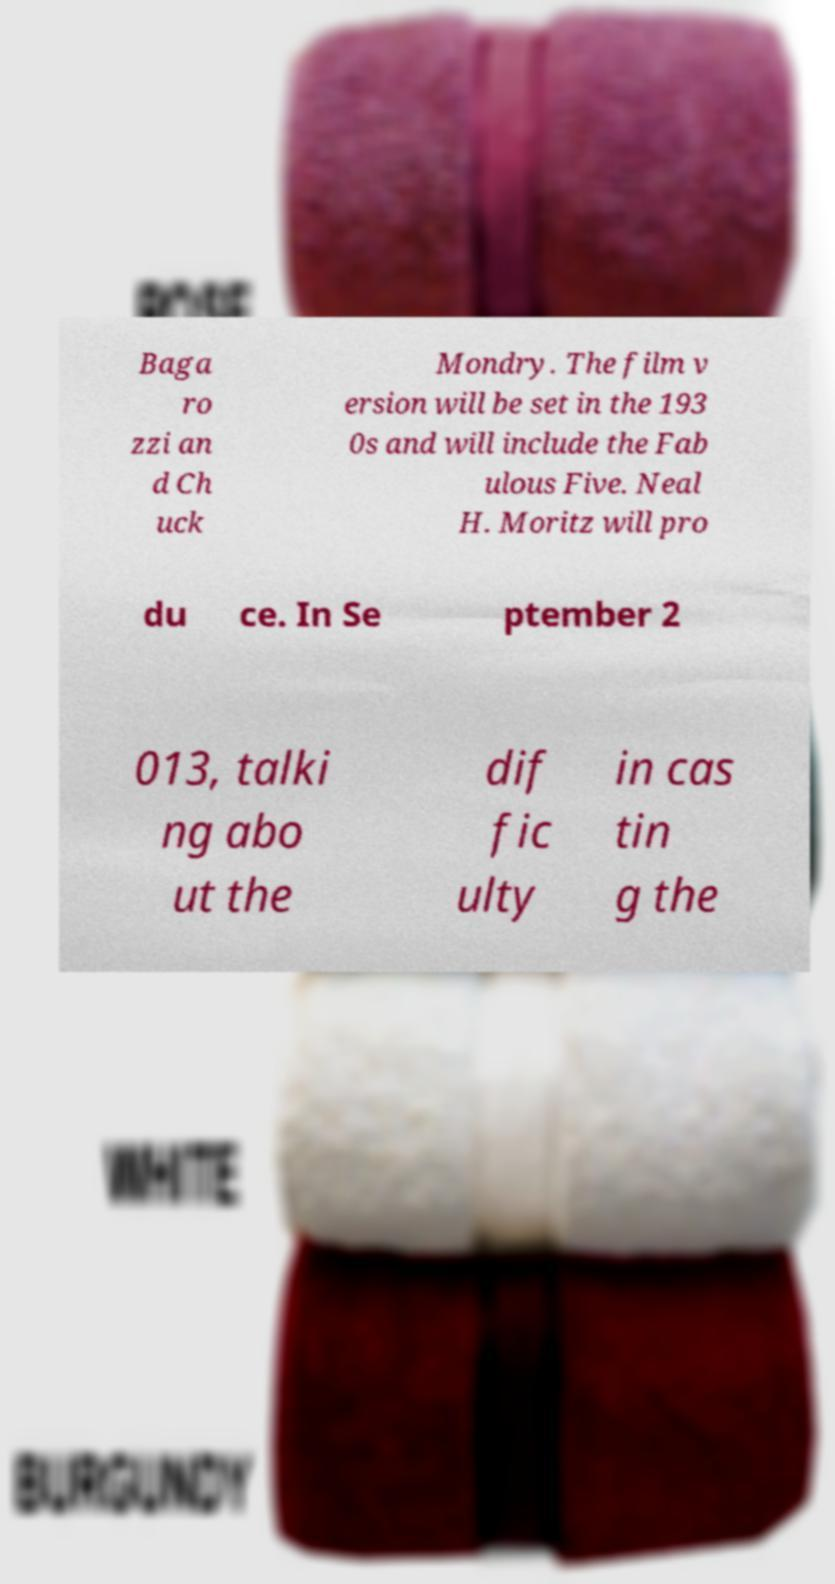I need the written content from this picture converted into text. Can you do that? Baga ro zzi an d Ch uck Mondry. The film v ersion will be set in the 193 0s and will include the Fab ulous Five. Neal H. Moritz will pro du ce. In Se ptember 2 013, talki ng abo ut the dif fic ulty in cas tin g the 